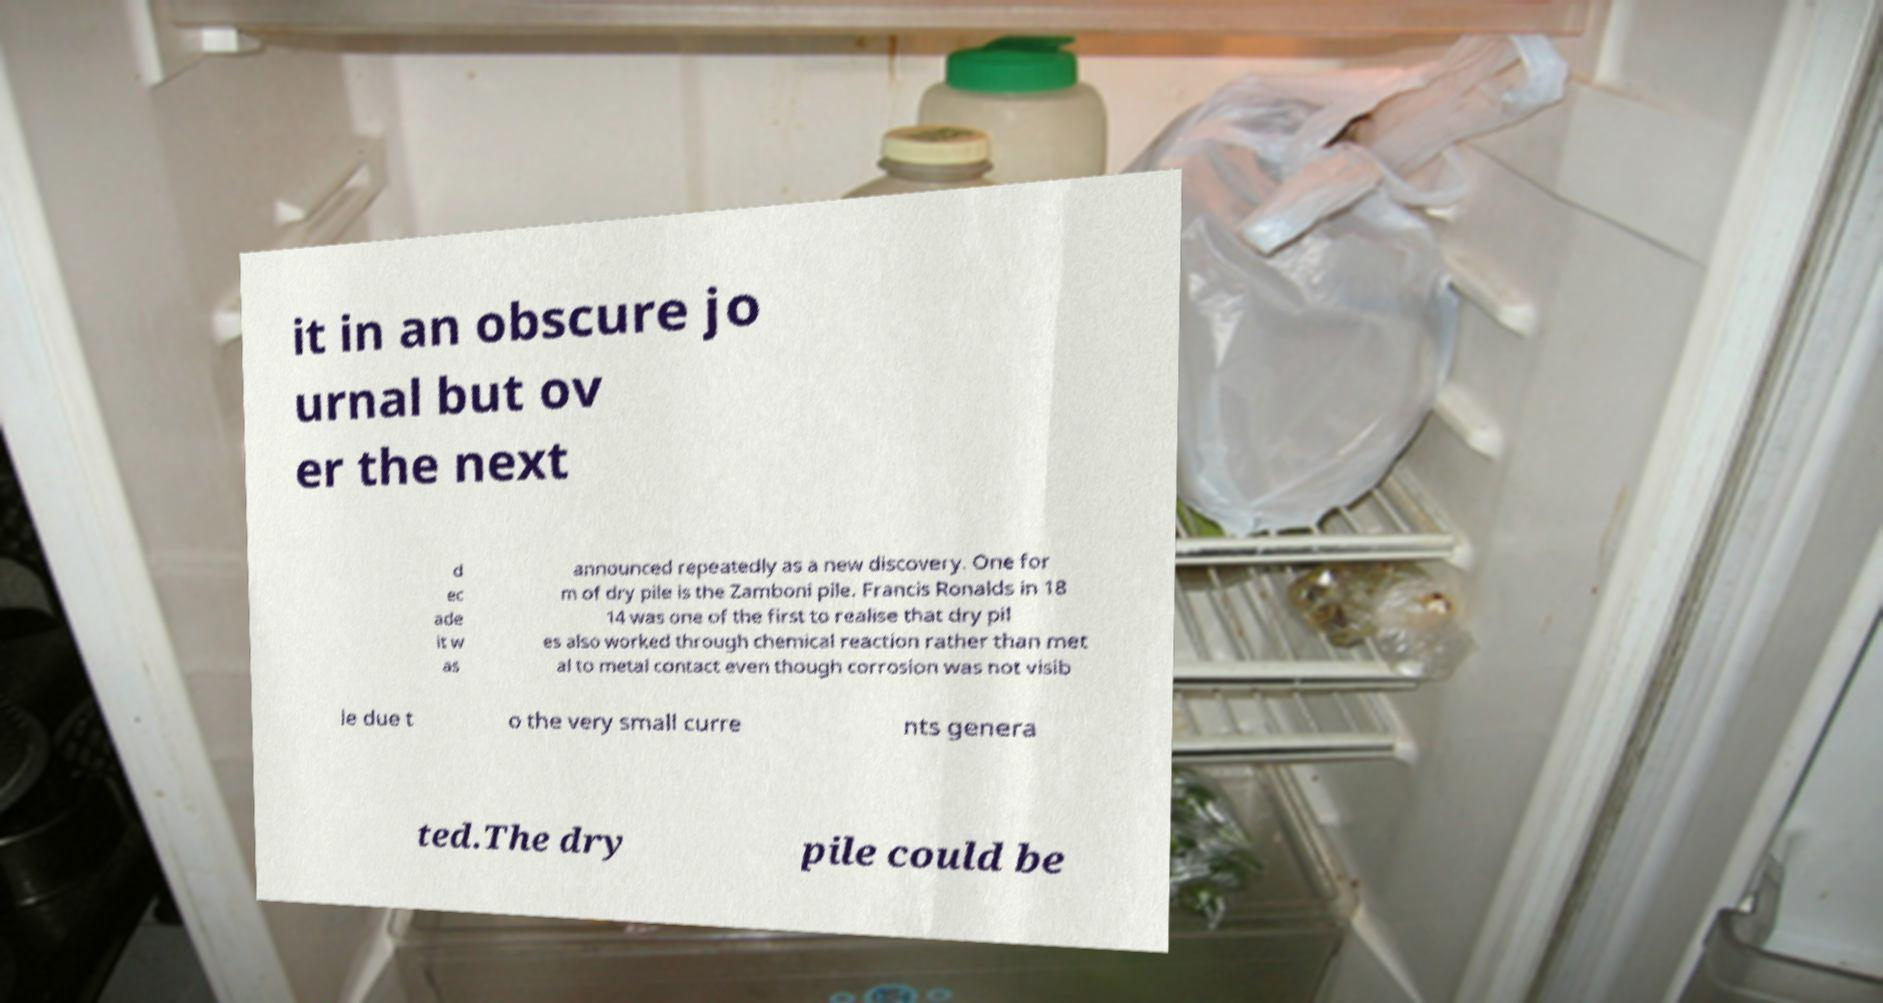There's text embedded in this image that I need extracted. Can you transcribe it verbatim? it in an obscure jo urnal but ov er the next d ec ade it w as announced repeatedly as a new discovery. One for m of dry pile is the Zamboni pile. Francis Ronalds in 18 14 was one of the first to realise that dry pil es also worked through chemical reaction rather than met al to metal contact even though corrosion was not visib le due t o the very small curre nts genera ted.The dry pile could be 